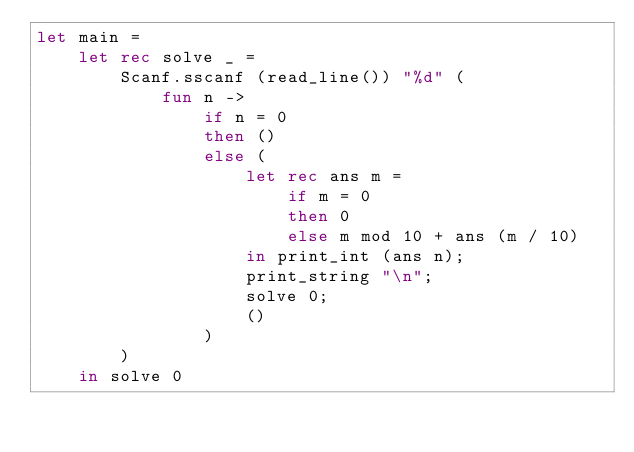Convert code to text. <code><loc_0><loc_0><loc_500><loc_500><_OCaml_>let main =
    let rec solve _ =
        Scanf.sscanf (read_line()) "%d" (
            fun n ->
                if n = 0
                then ()
                else (
                    let rec ans m =
                        if m = 0
                        then 0
                        else m mod 10 + ans (m / 10)
                    in print_int (ans n);
                    print_string "\n";
                    solve 0;
                    ()
                )
        )
    in solve 0</code> 